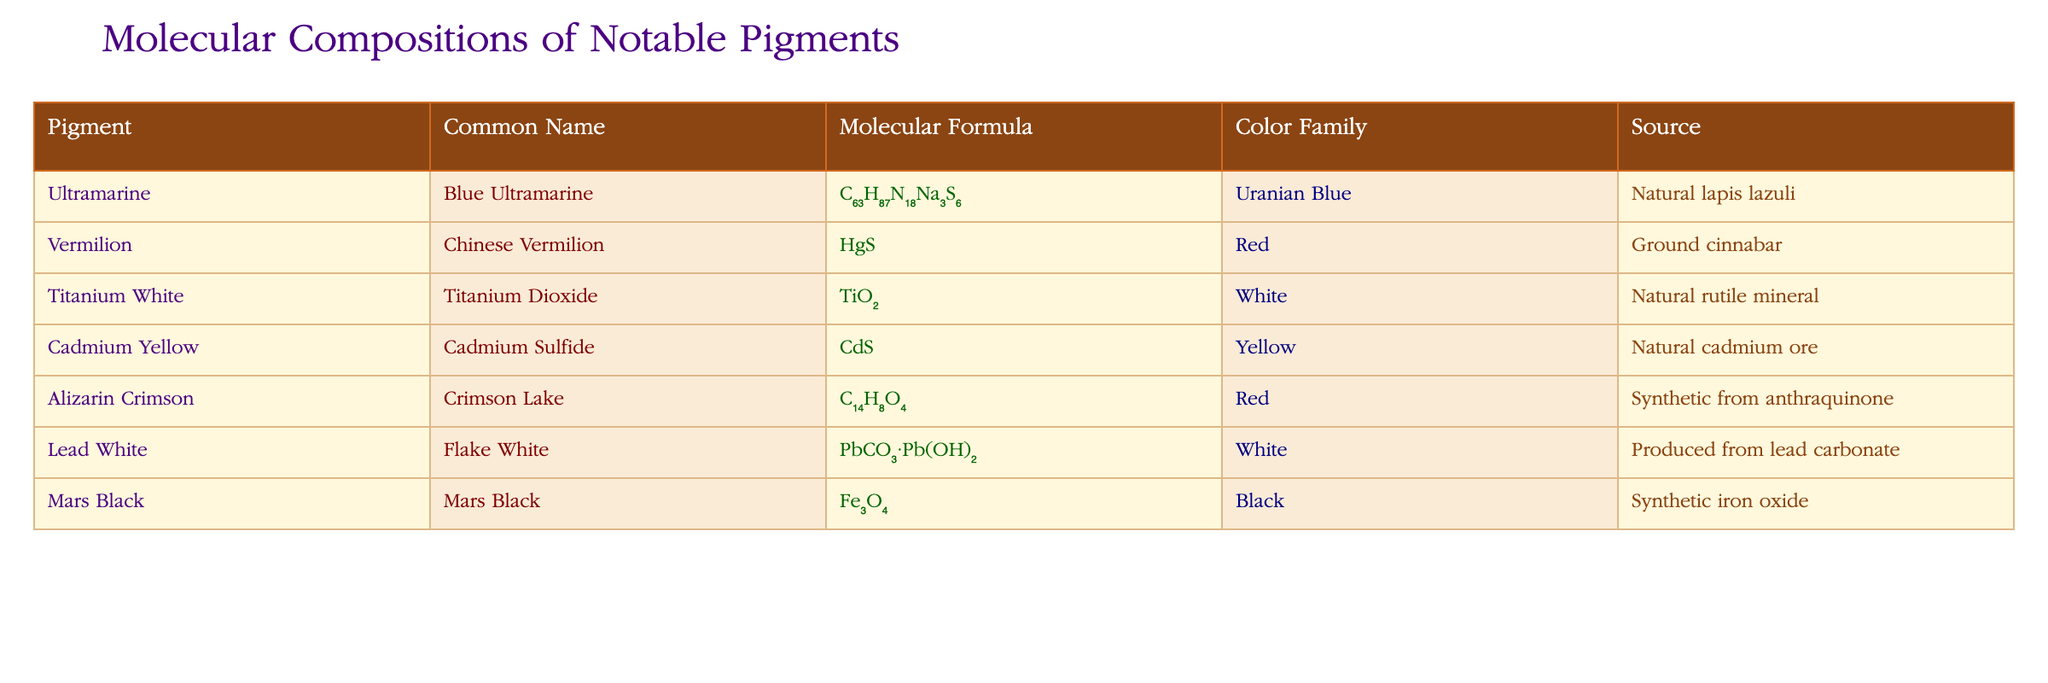What is the molecular formula for Cadmium Yellow? The table lists Cadmium Yellow under its common name, and in the corresponding row, the molecular formula provided is CdS.
Answer: CdS What color family does Vermilion belong to? From the table, we can see that Vermilion is categorized under the color family labeled as Red.
Answer: Red Is Lead White sourced from natural minerals? The table shows that Lead White is produced from lead carbonate, indicating it is not sourced from natural minerals but rather manufactured.
Answer: No Which pigment has the molecular formula C₁₄H₈O₄? By looking through the table and locating C₁₄H₈O₄, we find that it corresponds to Alizarin Crimson.
Answer: Alizarin Crimson How many pigments listed in the table are classified as White? Upon examining the colors associated with each pigment in the table, we see both Titanium White and Lead White are categorized as White, making a total of 2.
Answer: 2 Which of the pigments listed is a synthetic product? The table identifies Mars Black and Alizarin Crimson as synthetic, since their sources contain the term "synthetic."
Answer: Mars Black and Alizarin Crimson What is the difference between the number of Red pigments and Yellow pigments? From the table, we identify 2 Red pigments (Vermilion and Alizarin Crimson) and 1 Yellow pigment (Cadmium Yellow), leading to a difference of 2 - 1 = 1.
Answer: 1 What is the color family of Titanium White? The table indicates that Titanium White is in the color family labeled as White.
Answer: White Does Ultramarine have a natural or synthetic source? The table reflects that Ultramarine is sourced from natural lapis lazuli, showing it is a natural pigment.
Answer: Yes 